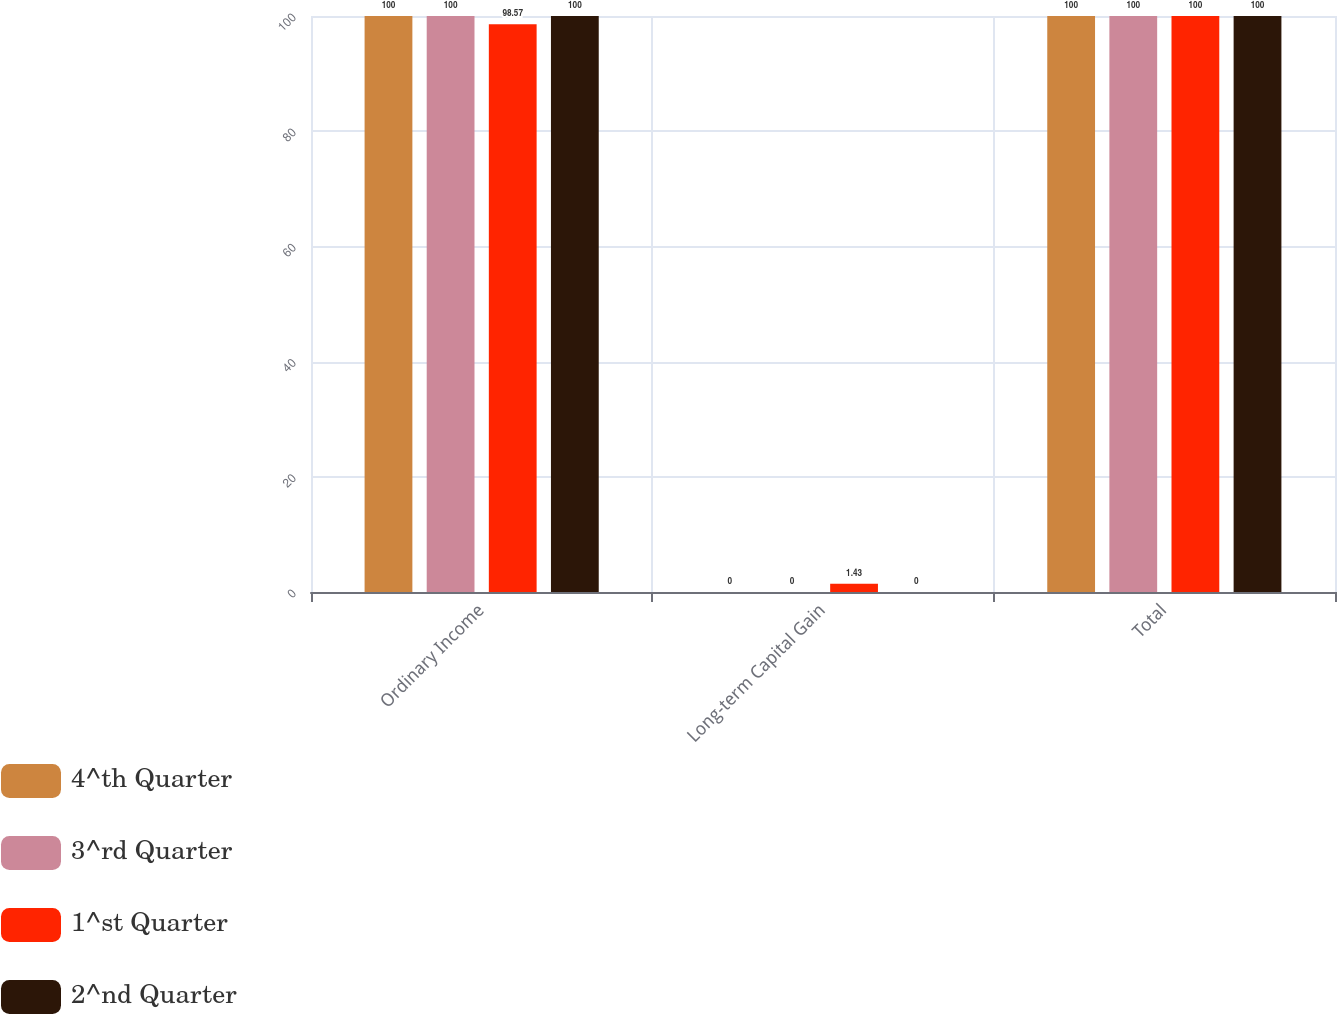Convert chart. <chart><loc_0><loc_0><loc_500><loc_500><stacked_bar_chart><ecel><fcel>Ordinary Income<fcel>Long-term Capital Gain<fcel>Total<nl><fcel>4^th Quarter<fcel>100<fcel>0<fcel>100<nl><fcel>3^rd Quarter<fcel>100<fcel>0<fcel>100<nl><fcel>1^st Quarter<fcel>98.57<fcel>1.43<fcel>100<nl><fcel>2^nd Quarter<fcel>100<fcel>0<fcel>100<nl></chart> 